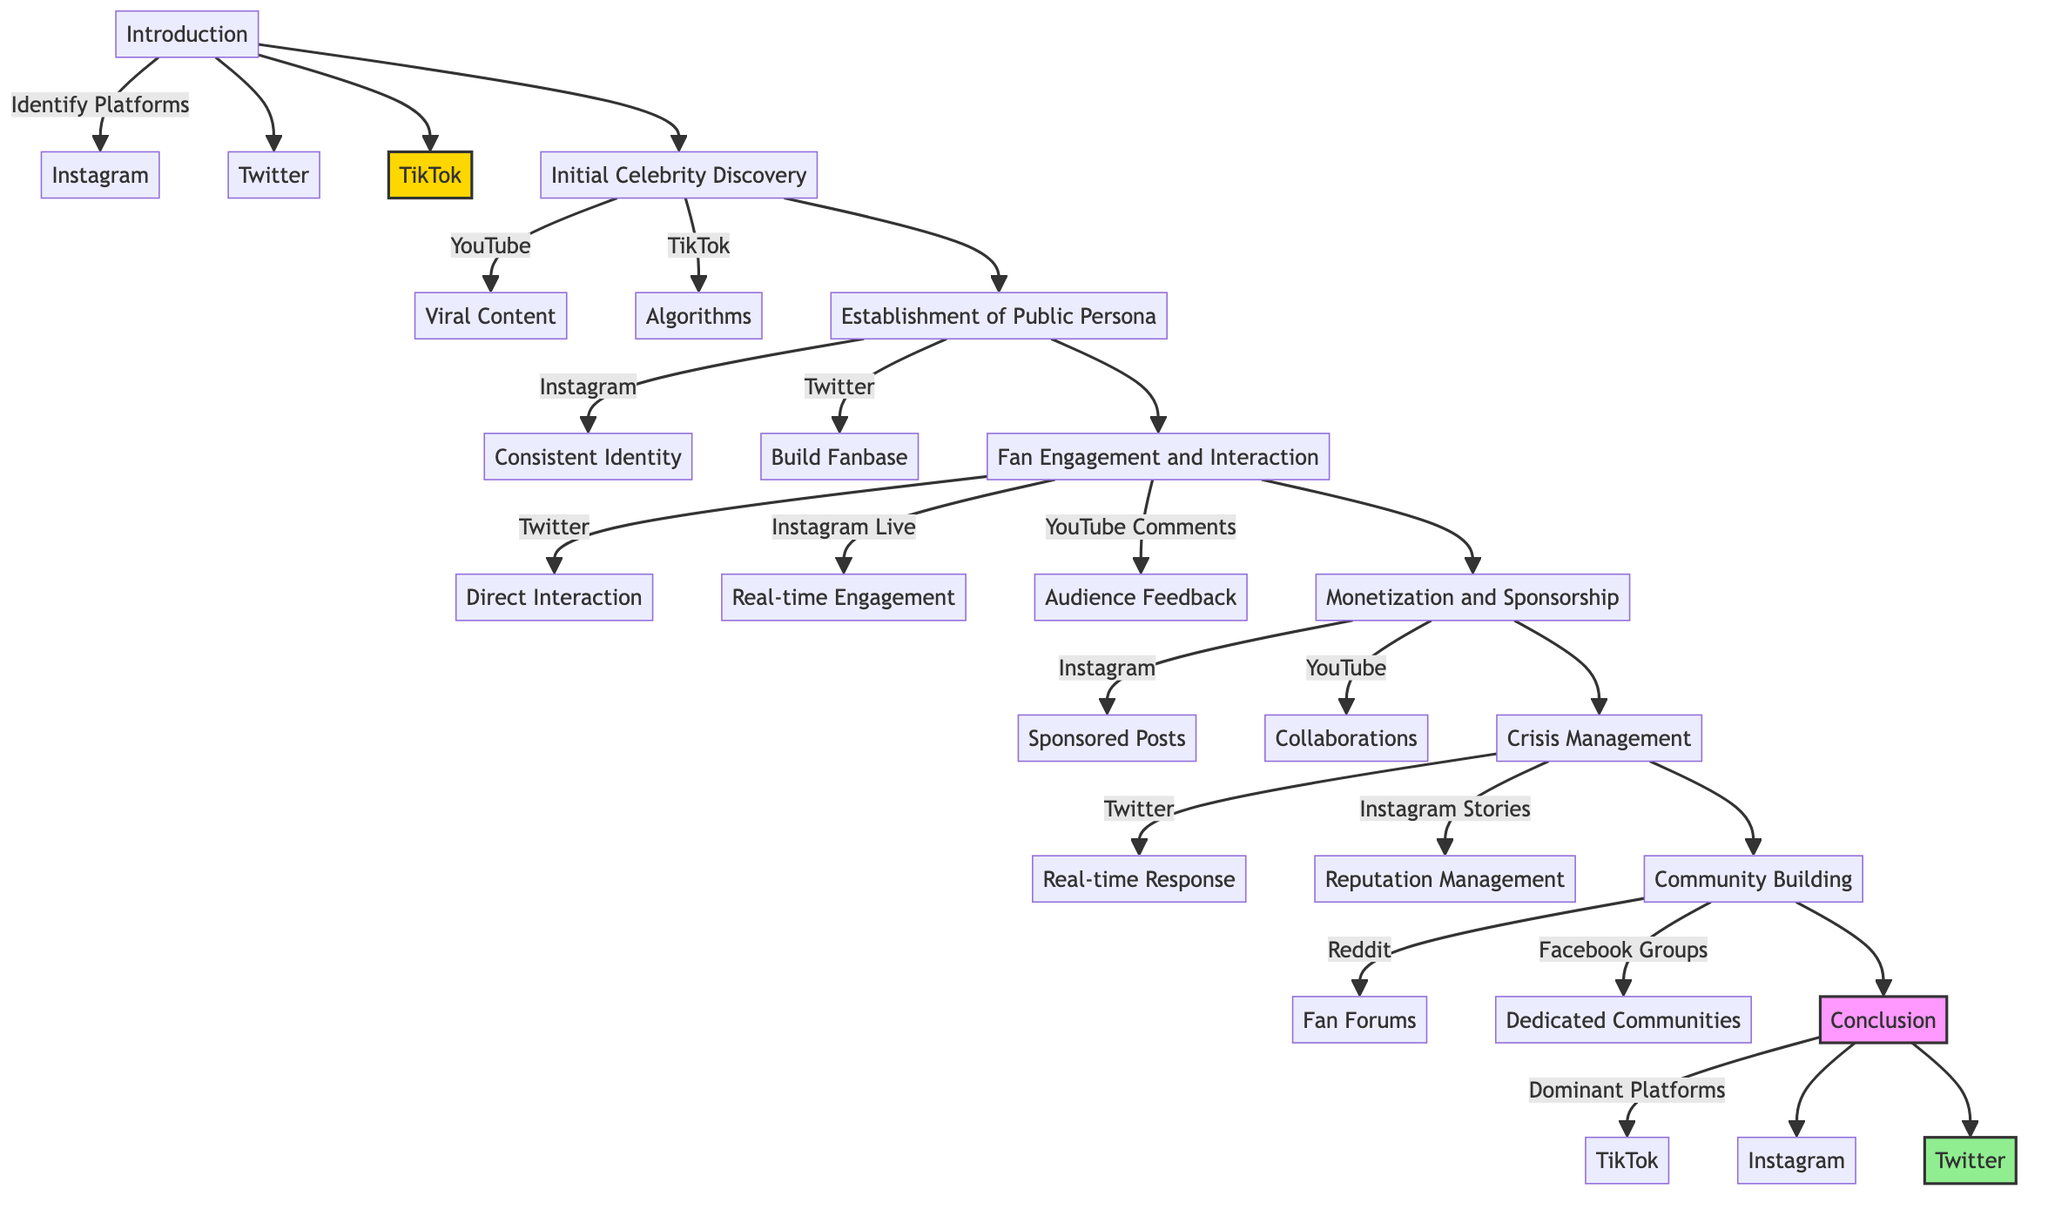What are the key platforms listed for initial celebrity discovery? The diagram specifies "YouTube" and "TikTok" as the key platforms under the "Initial Celebrity Discovery" element.
Answer: YouTube, TikTok Which platform is associated with crisis management? The "Crisis Management" element shows "Twitter" and "Instagram Stories" as key platforms used for handling public controversies.
Answer: Twitter, Instagram Stories How many elements are there in the pathway? By counting the numbered elements listed, there are six elements in the pathway: Initial Celebrity Discovery, Establishment of Public Persona, Fan Engagement and Interaction, Monetization and Sponsorship, Crisis Management, and Community Building.
Answer: 6 What role does Instagram play in fan engagement? Under "Fan Engagement and Interaction," Instagram is identified as a key platform for "Real-time Engagement," highlighting its role in allowing celebrities to connect directly with fans.
Answer: Real-time Engagement Which element comes after community building in the diagram? The pathway leads to the conclusion after "Community Building," indicating that it is the last element before concluding remarks about social media's dominance.
Answer: Conclusion Which social media platform is mentioned most frequently in the diagram? The repeated mentions of "Instagram" across multiple elements suggest it plays a significant role in various aspects of celebrity culture.
Answer: Instagram What is the primary focus of the "Establishment of Public Persona" element? This element focuses on crafting a consistent online identity to build a fanbase, demonstrating the importance of maintaining an appealing image on social media.
Answer: Consistent identity Which platform is emphasized for monetization and sponsorship? In the "Monetization and Sponsorship" element, "Instagram" and "YouTube" are highlighted as platforms where celebrities leverage their presence for sponsored content and collaborations.
Answer: Instagram, YouTube What is the primary outcome of community building according to the diagram? The diagram indicates that community building aims to create and nurture fan communities around a celebrity's persona, fostering loyalty and engagement among fans.
Answer: Fan communities 